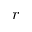<formula> <loc_0><loc_0><loc_500><loc_500>r</formula> 